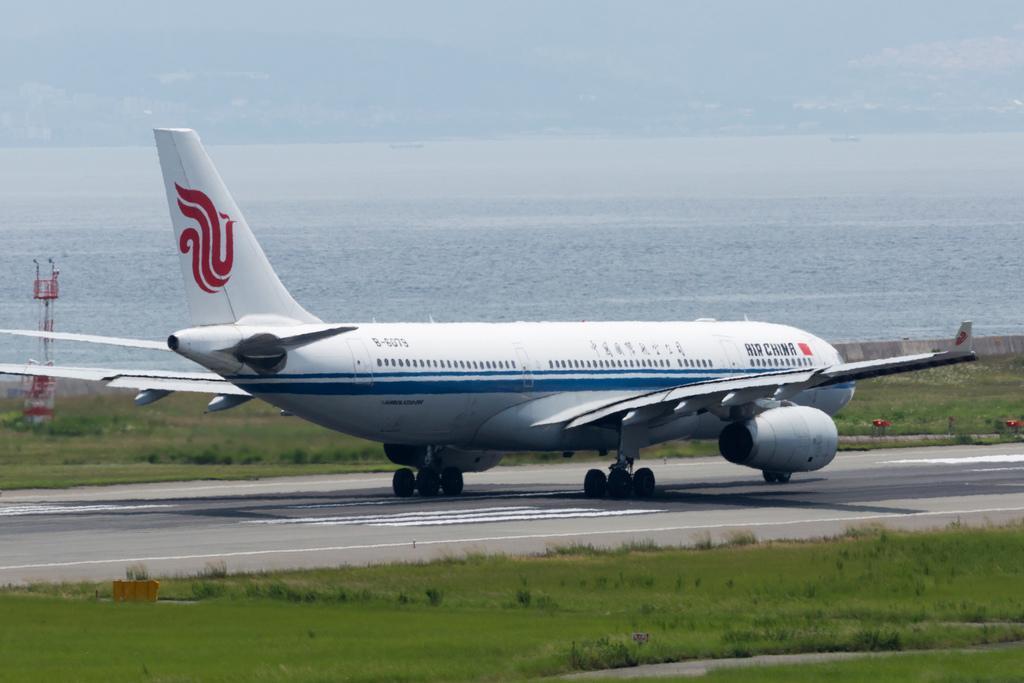Can you describe this image briefly? In the foreground of the picture there are plants and grass. In the center of the picture there is an airplane on the runway and there are plants, grass, pole and other objects. In the background there is a water body. 